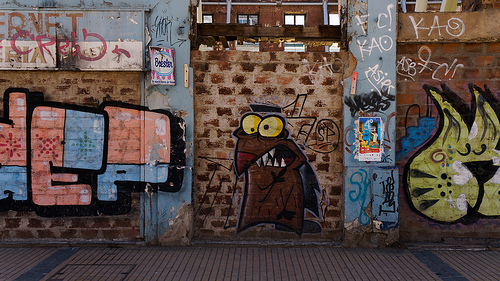<image>
Is the cat to the right of the hep graffiti? Yes. From this viewpoint, the cat is positioned to the right side relative to the hep graffiti. 